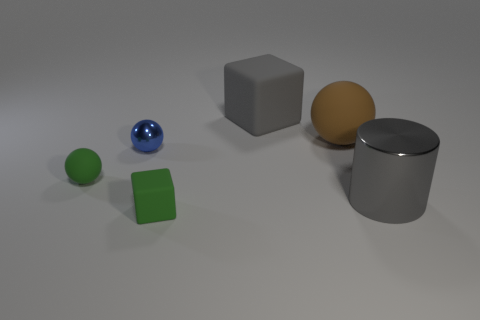Add 2 small shiny blocks. How many objects exist? 8 Subtract all cylinders. How many objects are left? 5 Subtract all green cubes. How many cubes are left? 1 Subtract all blue balls. How many balls are left? 2 Subtract 1 balls. How many balls are left? 2 Subtract all cyan matte blocks. Subtract all small matte things. How many objects are left? 4 Add 4 large brown matte things. How many large brown matte things are left? 5 Add 1 brown matte objects. How many brown matte objects exist? 2 Subtract 0 blue cylinders. How many objects are left? 6 Subtract all green cylinders. Subtract all brown spheres. How many cylinders are left? 1 